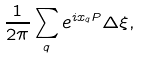<formula> <loc_0><loc_0><loc_500><loc_500>\frac { 1 } { 2 \pi } \sum _ { q } e ^ { i x _ { q } P } \Delta \xi ,</formula> 